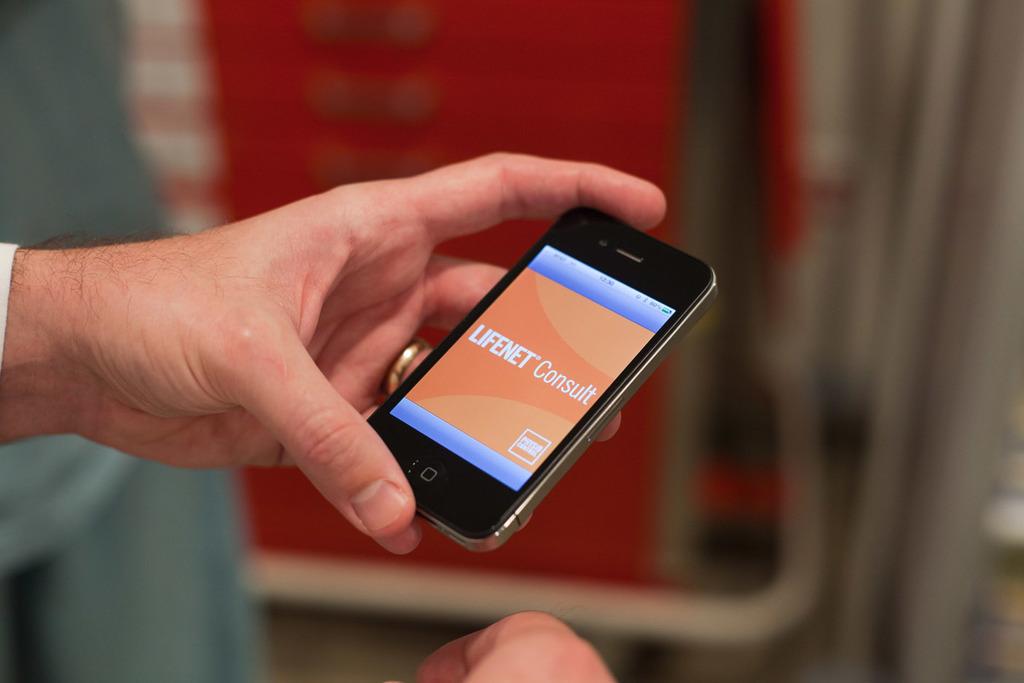What app is displayed on the phone?
Keep it short and to the point. Lifenet consult. 